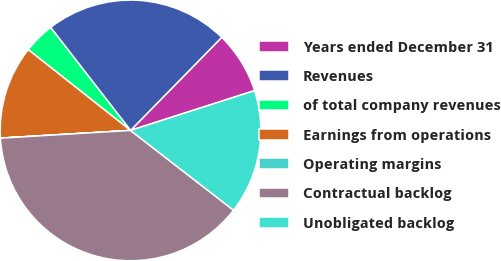Convert chart to OTSL. <chart><loc_0><loc_0><loc_500><loc_500><pie_chart><fcel>Years ended December 31<fcel>Revenues<fcel>of total company revenues<fcel>Earnings from operations<fcel>Operating margins<fcel>Contractual backlog<fcel>Unobligated backlog<nl><fcel>7.72%<fcel>22.84%<fcel>3.86%<fcel>11.58%<fcel>0.01%<fcel>38.57%<fcel>15.43%<nl></chart> 